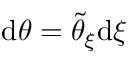Convert formula to latex. <formula><loc_0><loc_0><loc_500><loc_500>d \theta = \tilde { \theta } _ { \xi } d \xi</formula> 